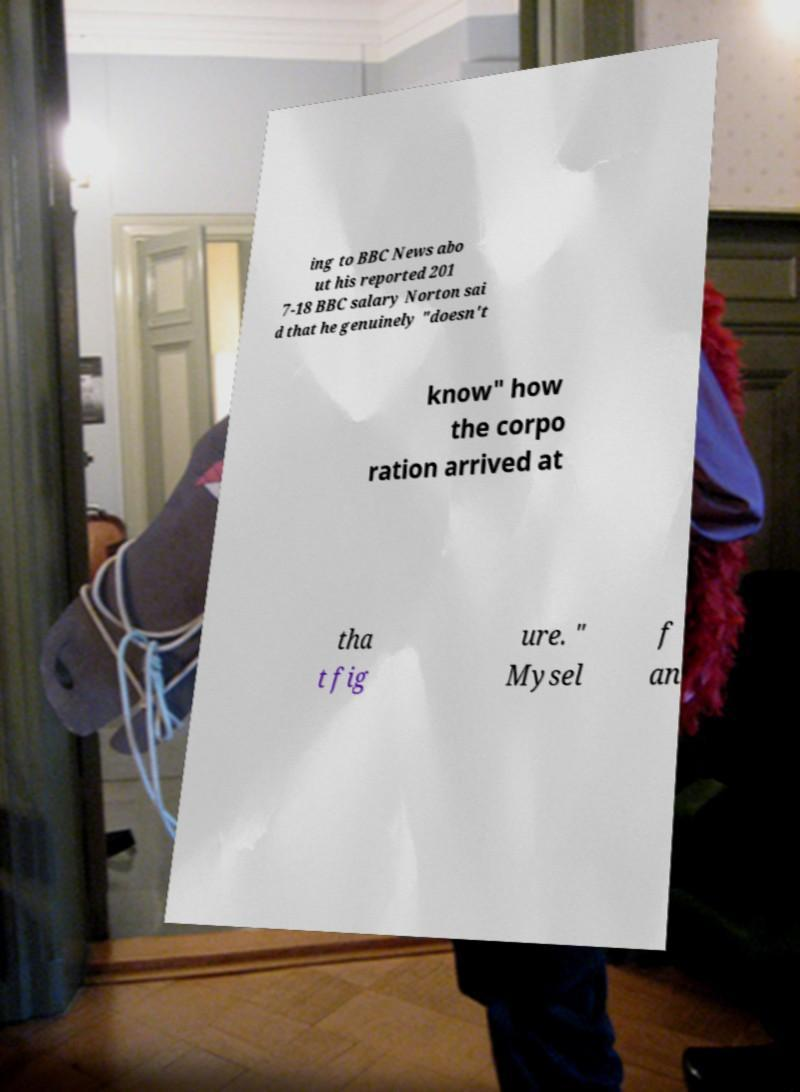Can you accurately transcribe the text from the provided image for me? ing to BBC News abo ut his reported 201 7-18 BBC salary Norton sai d that he genuinely "doesn't know" how the corpo ration arrived at tha t fig ure. " Mysel f an 